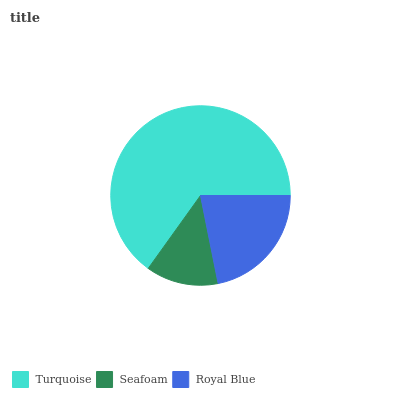Is Seafoam the minimum?
Answer yes or no. Yes. Is Turquoise the maximum?
Answer yes or no. Yes. Is Royal Blue the minimum?
Answer yes or no. No. Is Royal Blue the maximum?
Answer yes or no. No. Is Royal Blue greater than Seafoam?
Answer yes or no. Yes. Is Seafoam less than Royal Blue?
Answer yes or no. Yes. Is Seafoam greater than Royal Blue?
Answer yes or no. No. Is Royal Blue less than Seafoam?
Answer yes or no. No. Is Royal Blue the high median?
Answer yes or no. Yes. Is Royal Blue the low median?
Answer yes or no. Yes. Is Turquoise the high median?
Answer yes or no. No. Is Seafoam the low median?
Answer yes or no. No. 